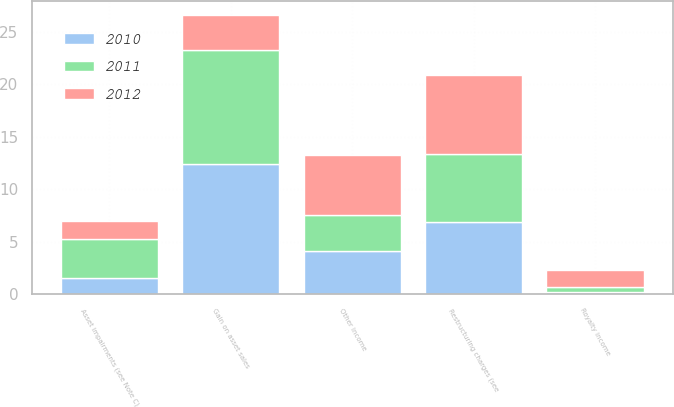Convert chart to OTSL. <chart><loc_0><loc_0><loc_500><loc_500><stacked_bar_chart><ecel><fcel>Gain on asset sales<fcel>Restructuring charges (see<fcel>Asset impairments (see Note C)<fcel>Royalty income<fcel>Other income<nl><fcel>2012<fcel>3.3<fcel>7.5<fcel>1.7<fcel>1.6<fcel>5.8<nl><fcel>2011<fcel>10.9<fcel>6.5<fcel>3.75<fcel>0.5<fcel>3.4<nl><fcel>2010<fcel>12.4<fcel>6.9<fcel>1.5<fcel>0.2<fcel>4.1<nl></chart> 